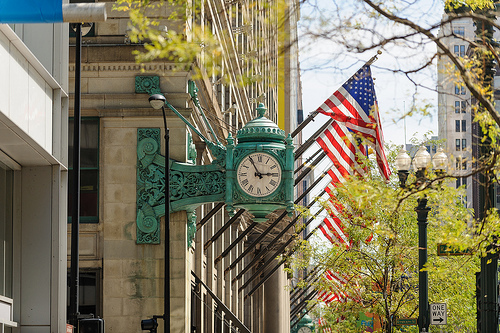<image>
Can you confirm if the flag is behind the clock? Yes. From this viewpoint, the flag is positioned behind the clock, with the clock partially or fully occluding the flag. 